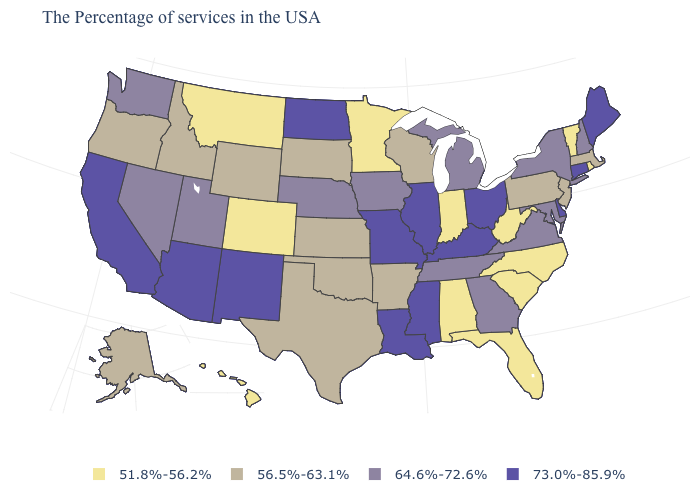Does the first symbol in the legend represent the smallest category?
Concise answer only. Yes. What is the value of New Hampshire?
Be succinct. 64.6%-72.6%. Among the states that border Massachusetts , does New York have the lowest value?
Be succinct. No. What is the value of Idaho?
Keep it brief. 56.5%-63.1%. What is the highest value in the USA?
Write a very short answer. 73.0%-85.9%. Name the states that have a value in the range 73.0%-85.9%?
Keep it brief. Maine, Connecticut, Delaware, Ohio, Kentucky, Illinois, Mississippi, Louisiana, Missouri, North Dakota, New Mexico, Arizona, California. What is the highest value in the Northeast ?
Give a very brief answer. 73.0%-85.9%. What is the value of Alabama?
Give a very brief answer. 51.8%-56.2%. What is the value of Vermont?
Answer briefly. 51.8%-56.2%. What is the value of North Carolina?
Answer briefly. 51.8%-56.2%. What is the value of Vermont?
Keep it brief. 51.8%-56.2%. What is the value of New York?
Keep it brief. 64.6%-72.6%. Does Indiana have the highest value in the MidWest?
Answer briefly. No. Does Alaska have the same value as Michigan?
Be succinct. No. What is the value of Arkansas?
Keep it brief. 56.5%-63.1%. 